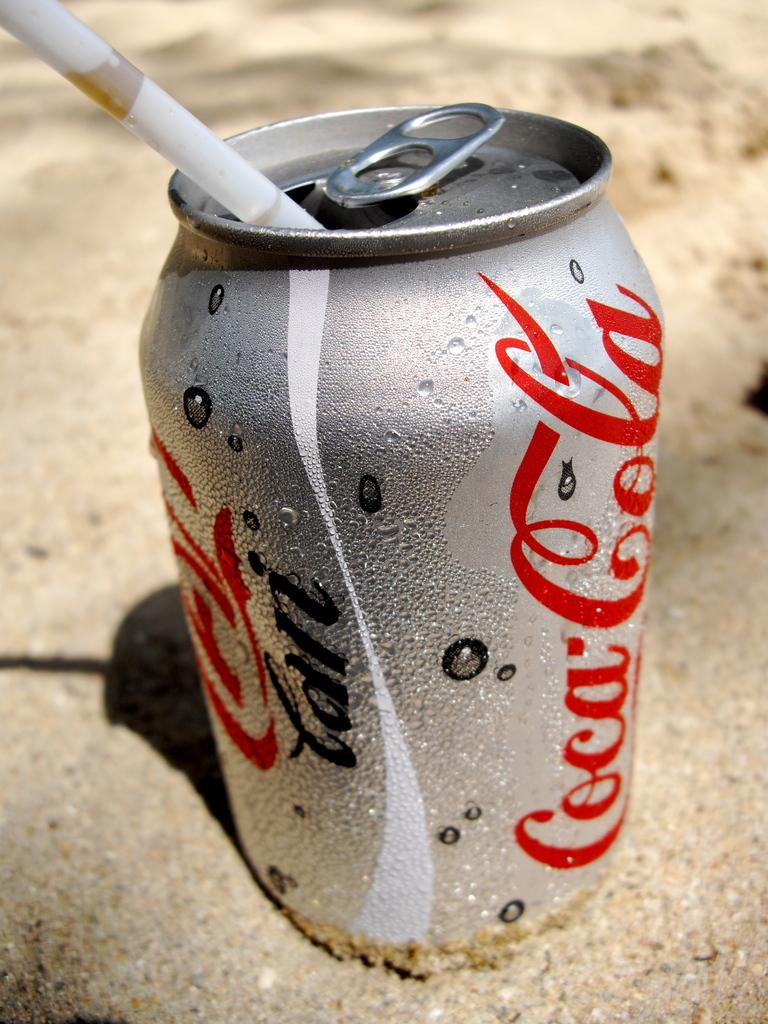<image>
Write a terse but informative summary of the picture. A silver can of soda that says Coca-Cola is in some sand and has a straw in it. 